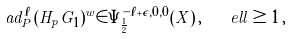Convert formula to latex. <formula><loc_0><loc_0><loc_500><loc_500>\ a d _ { P } ^ { \ell } ( H _ { p } G _ { 1 } ) ^ { w } \in \Psi ^ { - \ell + \epsilon , 0 , 0 } _ { \frac { 1 } { 2 } } ( X ) \, , \quad e l l \geq 1 \, ,</formula> 